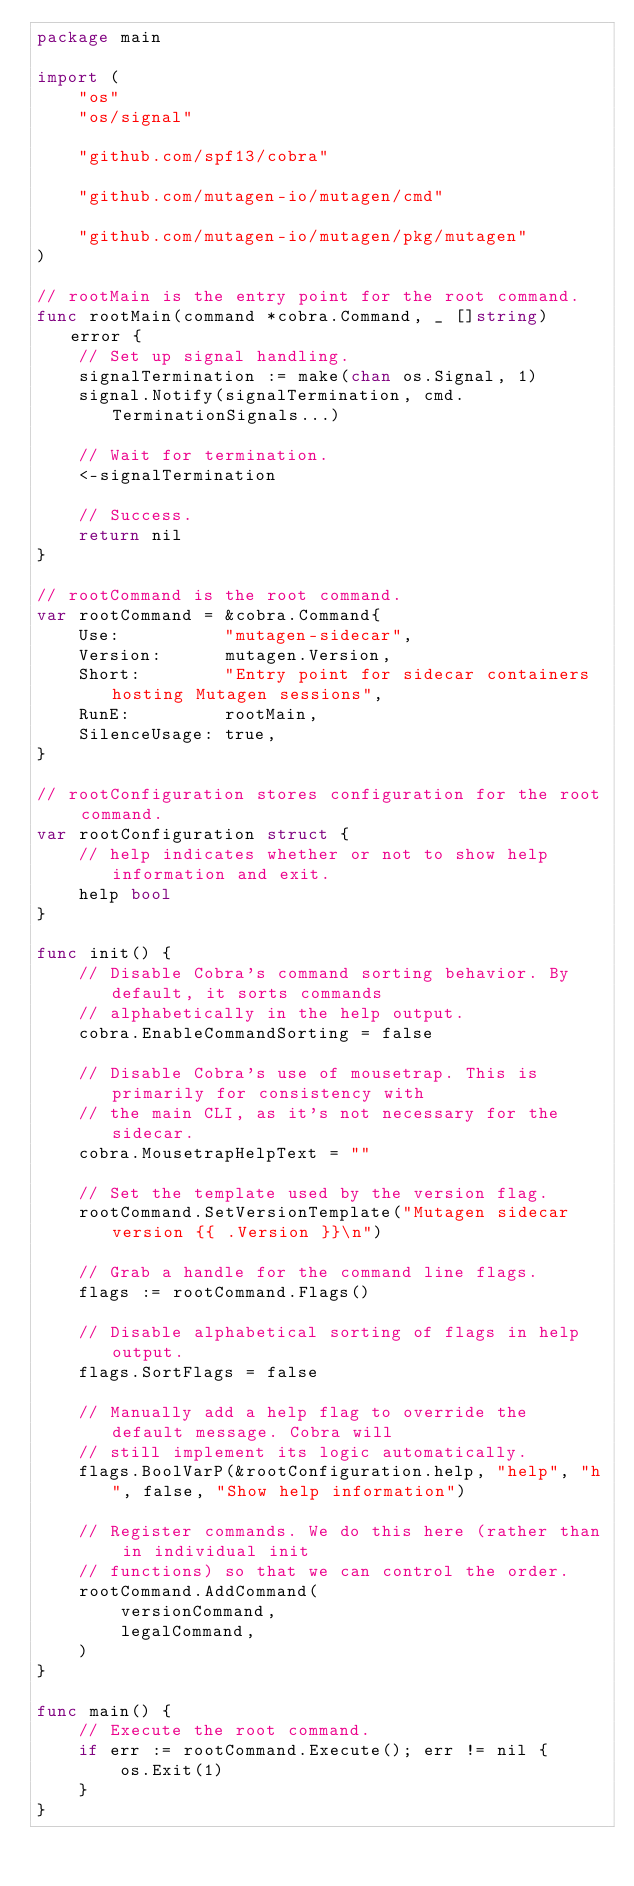<code> <loc_0><loc_0><loc_500><loc_500><_Go_>package main

import (
	"os"
	"os/signal"

	"github.com/spf13/cobra"

	"github.com/mutagen-io/mutagen/cmd"

	"github.com/mutagen-io/mutagen/pkg/mutagen"
)

// rootMain is the entry point for the root command.
func rootMain(command *cobra.Command, _ []string) error {
	// Set up signal handling.
	signalTermination := make(chan os.Signal, 1)
	signal.Notify(signalTermination, cmd.TerminationSignals...)

	// Wait for termination.
	<-signalTermination

	// Success.
	return nil
}

// rootCommand is the root command.
var rootCommand = &cobra.Command{
	Use:          "mutagen-sidecar",
	Version:      mutagen.Version,
	Short:        "Entry point for sidecar containers hosting Mutagen sessions",
	RunE:         rootMain,
	SilenceUsage: true,
}

// rootConfiguration stores configuration for the root command.
var rootConfiguration struct {
	// help indicates whether or not to show help information and exit.
	help bool
}

func init() {
	// Disable Cobra's command sorting behavior. By default, it sorts commands
	// alphabetically in the help output.
	cobra.EnableCommandSorting = false

	// Disable Cobra's use of mousetrap. This is primarily for consistency with
	// the main CLI, as it's not necessary for the sidecar.
	cobra.MousetrapHelpText = ""

	// Set the template used by the version flag.
	rootCommand.SetVersionTemplate("Mutagen sidecar version {{ .Version }}\n")

	// Grab a handle for the command line flags.
	flags := rootCommand.Flags()

	// Disable alphabetical sorting of flags in help output.
	flags.SortFlags = false

	// Manually add a help flag to override the default message. Cobra will
	// still implement its logic automatically.
	flags.BoolVarP(&rootConfiguration.help, "help", "h", false, "Show help information")

	// Register commands. We do this here (rather than in individual init
	// functions) so that we can control the order.
	rootCommand.AddCommand(
		versionCommand,
		legalCommand,
	)
}

func main() {
	// Execute the root command.
	if err := rootCommand.Execute(); err != nil {
		os.Exit(1)
	}
}
</code> 